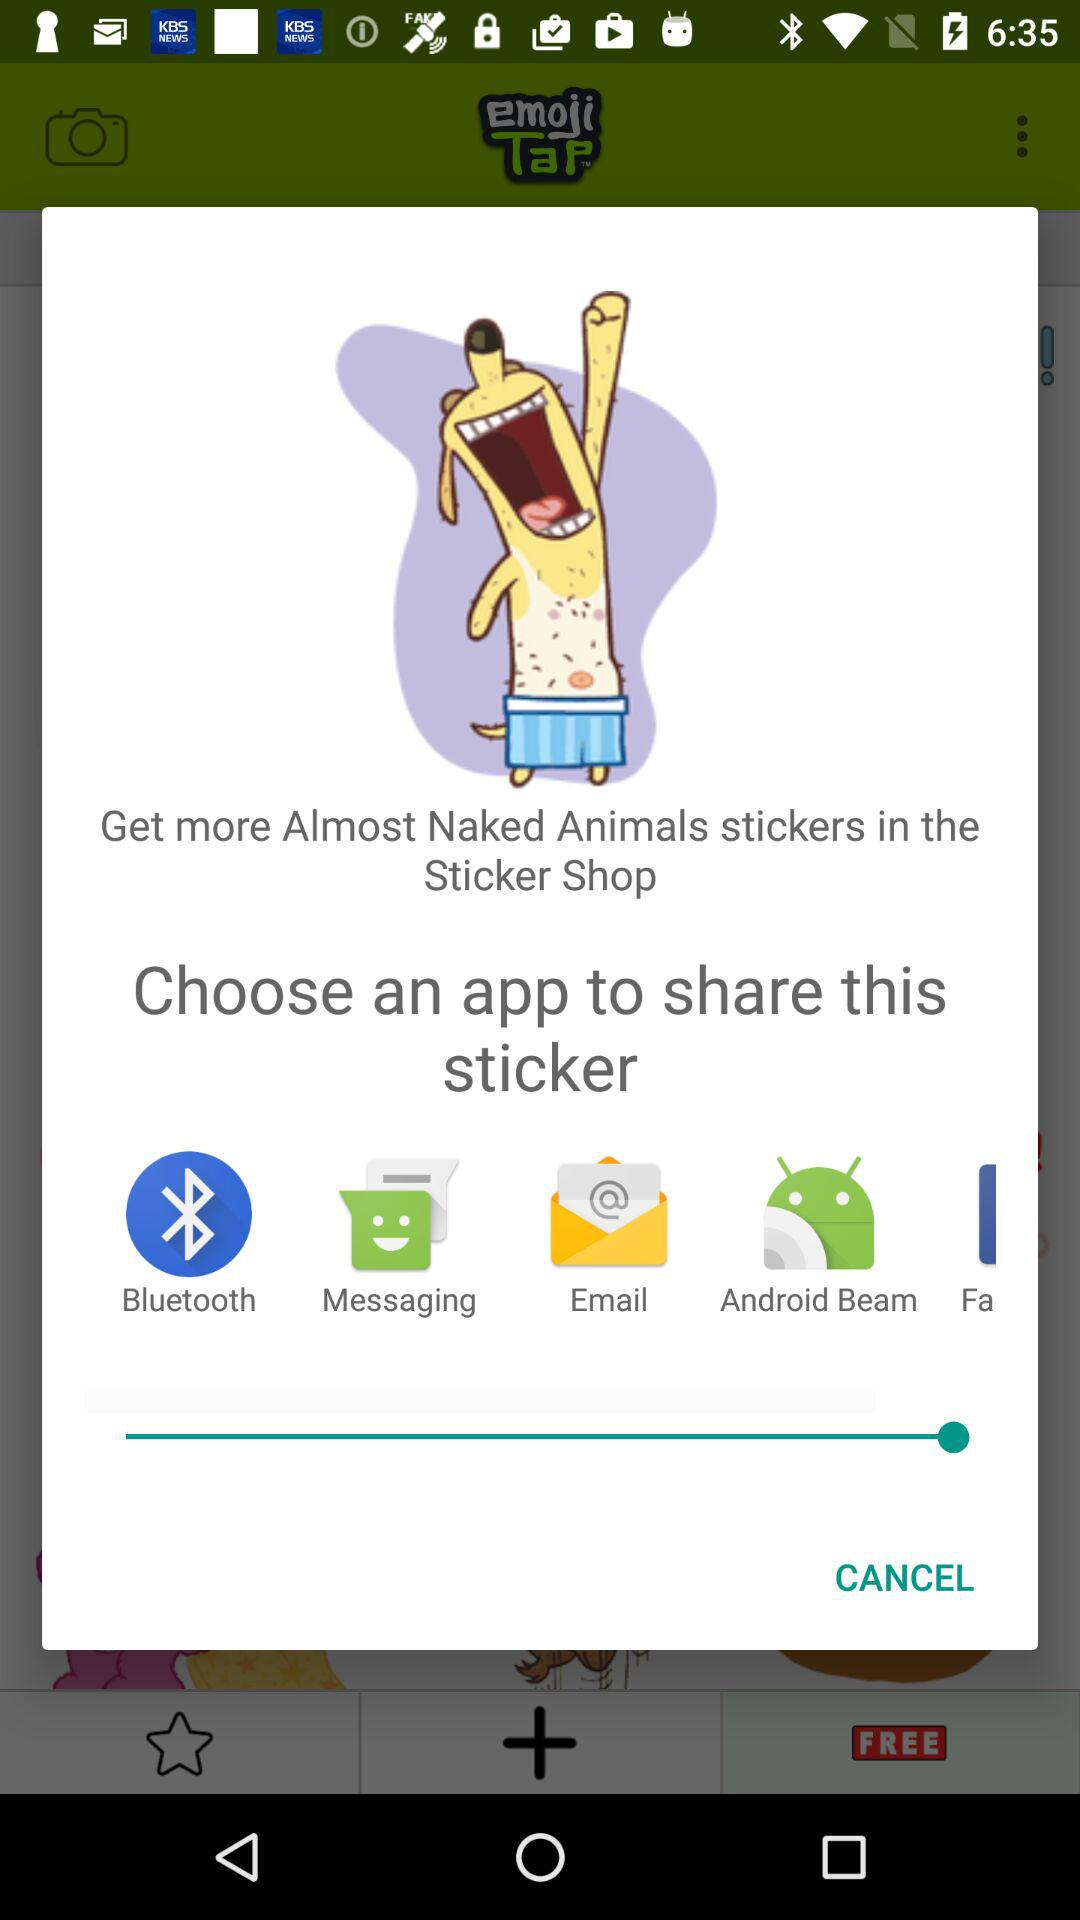Which application can be used to share the sticker? The applications that can be used to share the sticker are "Bluetooth", "Messaging", "Email" and "Android Beam". 